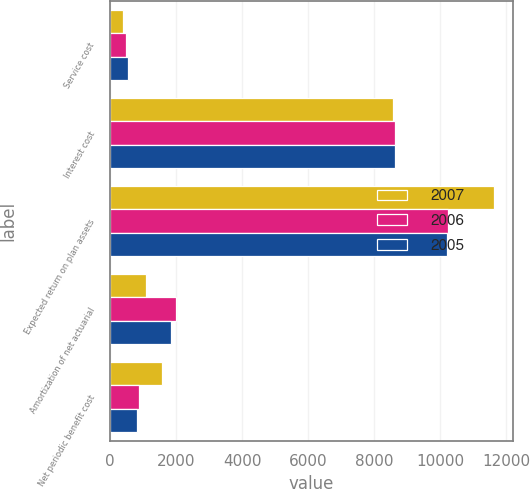<chart> <loc_0><loc_0><loc_500><loc_500><stacked_bar_chart><ecel><fcel>Service cost<fcel>Interest cost<fcel>Expected return on plan assets<fcel>Amortization of net actuarial<fcel>Net periodic benefit cost<nl><fcel>2007<fcel>384<fcel>8564<fcel>11618<fcel>1089<fcel>1581<nl><fcel>2006<fcel>499<fcel>8624<fcel>10250<fcel>1999<fcel>872<nl><fcel>2005<fcel>557<fcel>8630<fcel>10211<fcel>1850<fcel>826<nl></chart> 